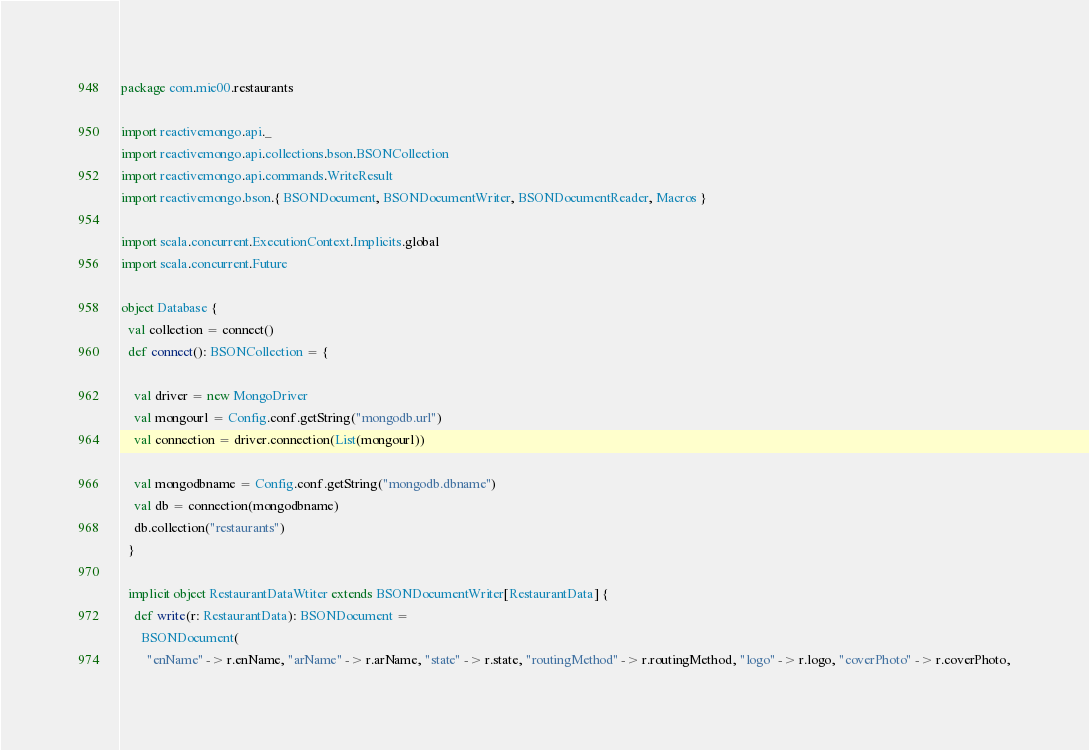<code> <loc_0><loc_0><loc_500><loc_500><_Scala_>package com.mie00.restaurants

import reactivemongo.api._
import reactivemongo.api.collections.bson.BSONCollection
import reactivemongo.api.commands.WriteResult
import reactivemongo.bson.{ BSONDocument, BSONDocumentWriter, BSONDocumentReader, Macros }

import scala.concurrent.ExecutionContext.Implicits.global
import scala.concurrent.Future

object Database {
  val collection = connect()
  def connect(): BSONCollection = {

    val driver = new MongoDriver
    val mongourl = Config.conf.getString("mongodb.url")
    val connection = driver.connection(List(mongourl))

    val mongodbname = Config.conf.getString("mongodb.dbname")
    val db = connection(mongodbname)
    db.collection("restaurants")
  }

  implicit object RestaurantDataWtiter extends BSONDocumentWriter[RestaurantData] {
    def write(r: RestaurantData): BSONDocument =
      BSONDocument(
        "enName" -> r.enName, "arName" -> r.arName, "state" -> r.state, "routingMethod" -> r.routingMethod, "logo" -> r.logo, "coverPhoto" -> r.coverPhoto,</code> 